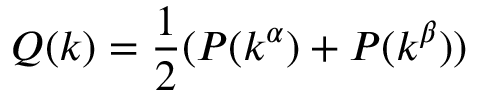Convert formula to latex. <formula><loc_0><loc_0><loc_500><loc_500>Q ( k ) = \frac { 1 } { 2 } ( P ( k ^ { \alpha } ) + P ( k ^ { \beta } ) )</formula> 